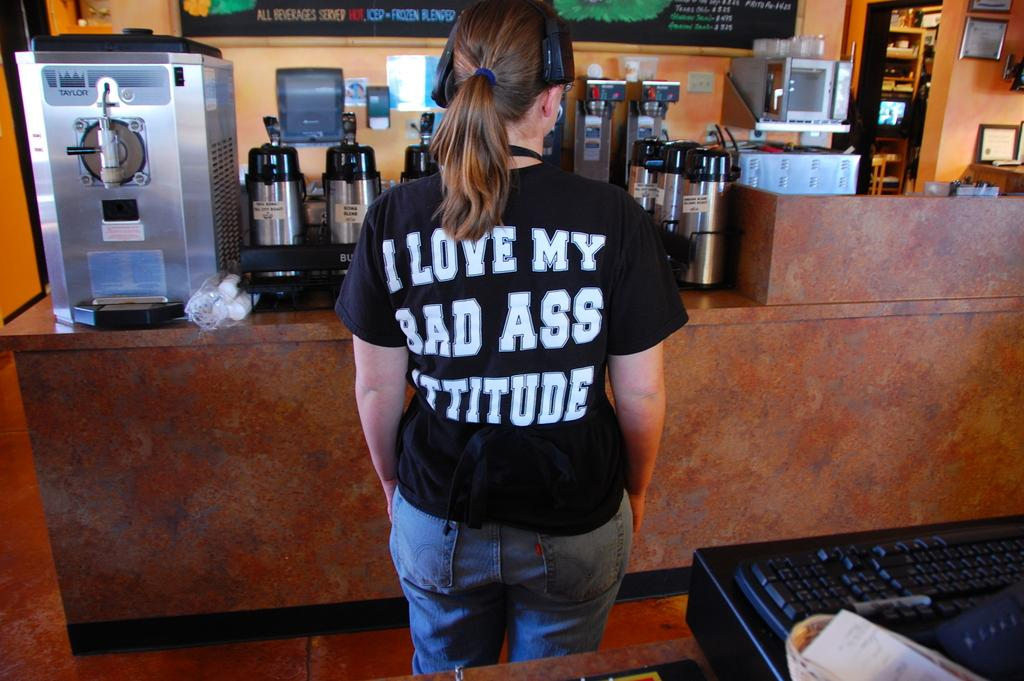<image>
Offer a succinct explanation of the picture presented. a girl wearing a shirt saying I Love My waiting for a coffee order 